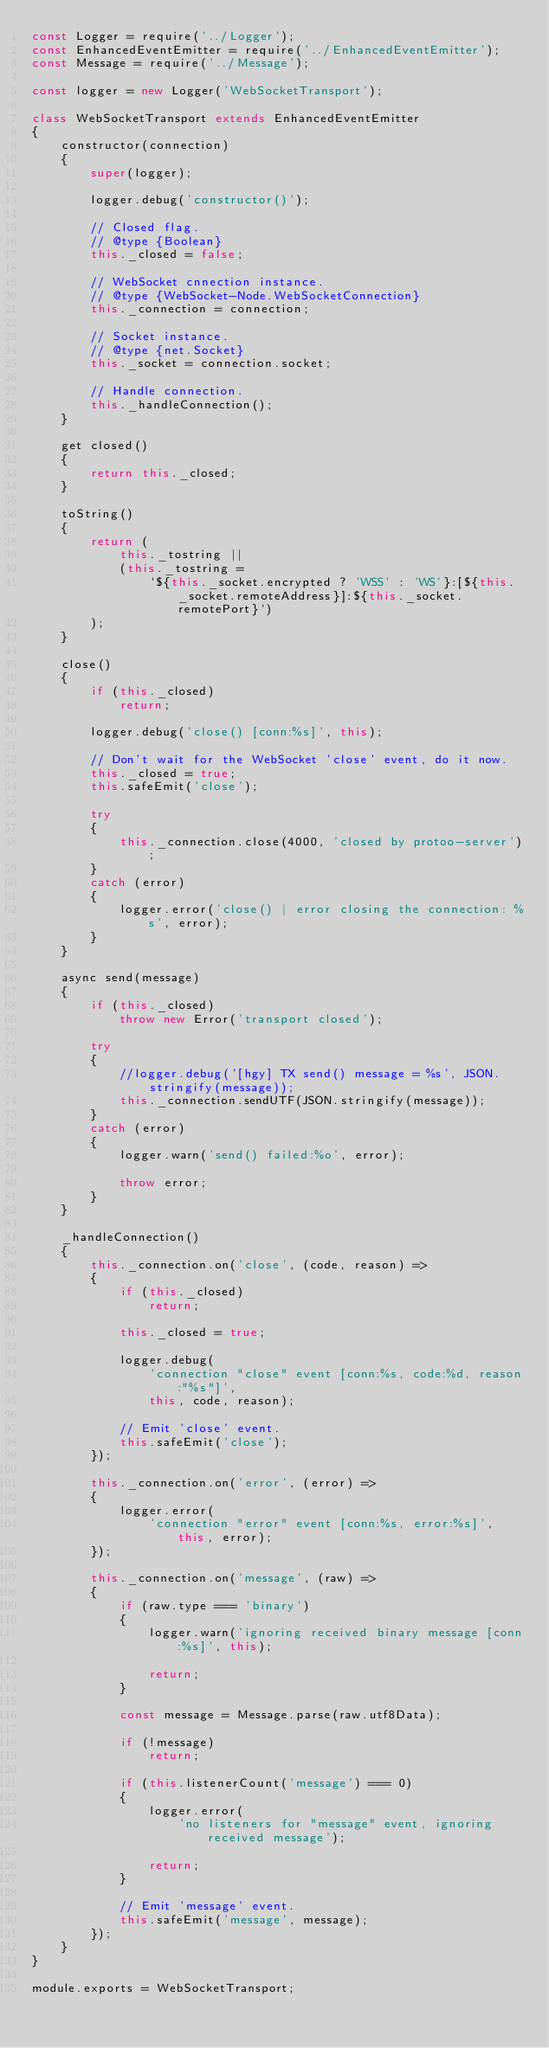Convert code to text. <code><loc_0><loc_0><loc_500><loc_500><_JavaScript_>const Logger = require('../Logger');
const EnhancedEventEmitter = require('../EnhancedEventEmitter');
const Message = require('../Message');

const logger = new Logger('WebSocketTransport');

class WebSocketTransport extends EnhancedEventEmitter
{
	constructor(connection)
	{
		super(logger);

		logger.debug('constructor()');

		// Closed flag.
		// @type {Boolean}
		this._closed = false;

		// WebSocket cnnection instance.
		// @type {WebSocket-Node.WebSocketConnection}
		this._connection = connection;

		// Socket instance.
		// @type {net.Socket}
		this._socket = connection.socket;

		// Handle connection.
		this._handleConnection();
	}

	get closed()
	{
		return this._closed;
	}

	toString()
	{
		return (
			this._tostring ||
			(this._tostring =
				`${this._socket.encrypted ? 'WSS' : 'WS'}:[${this._socket.remoteAddress}]:${this._socket.remotePort}`)
		);
	}

	close()
	{
		if (this._closed)
			return;

		logger.debug('close() [conn:%s]', this);

		// Don't wait for the WebSocket 'close' event, do it now.
		this._closed = true;
		this.safeEmit('close');

		try
		{
			this._connection.close(4000, 'closed by protoo-server');
		}
		catch (error)
		{
			logger.error('close() | error closing the connection: %s', error);
		}
	}

	async send(message)
	{
		if (this._closed)
			throw new Error('transport closed');

		try
		{
            //logger.debug('[hgy] TX send() message = %s', JSON.stringify(message));
			this._connection.sendUTF(JSON.stringify(message));
		}
		catch (error)
		{
			logger.warn('send() failed:%o', error);

			throw error;
		}
	}

	_handleConnection()
	{
		this._connection.on('close', (code, reason) =>
		{
			if (this._closed)
				return;

			this._closed = true;

			logger.debug(
				'connection "close" event [conn:%s, code:%d, reason:"%s"]',
				this, code, reason);

			// Emit 'close' event.
			this.safeEmit('close');
		});

		this._connection.on('error', (error) =>
		{
			logger.error(
				'connection "error" event [conn:%s, error:%s]', this, error);
		});

		this._connection.on('message', (raw) =>
		{
			if (raw.type === 'binary')
			{
				logger.warn('ignoring received binary message [conn:%s]', this);

				return;
			}

			const message = Message.parse(raw.utf8Data);

			if (!message)
				return;

			if (this.listenerCount('message') === 0)
			{
				logger.error(
					'no listeners for "message" event, ignoring received message');

				return;
			}

			// Emit 'message' event.
			this.safeEmit('message', message);
		});
	}
}

module.exports = WebSocketTransport;
</code> 